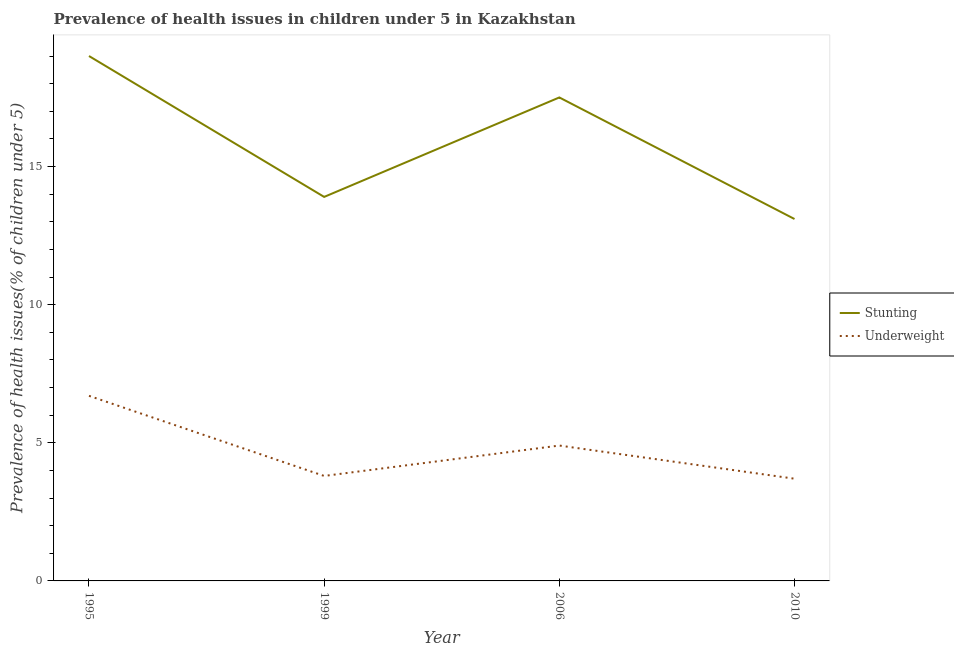How many different coloured lines are there?
Ensure brevity in your answer.  2. Across all years, what is the minimum percentage of stunted children?
Your answer should be very brief. 13.1. What is the total percentage of underweight children in the graph?
Offer a very short reply. 19.1. What is the difference between the percentage of underweight children in 1999 and that in 2006?
Your response must be concise. -1.1. What is the difference between the percentage of underweight children in 1999 and the percentage of stunted children in 2010?
Keep it short and to the point. -9.3. What is the average percentage of stunted children per year?
Ensure brevity in your answer.  15.88. In the year 2010, what is the difference between the percentage of underweight children and percentage of stunted children?
Give a very brief answer. -9.4. In how many years, is the percentage of underweight children greater than 13 %?
Ensure brevity in your answer.  0. What is the ratio of the percentage of stunted children in 1995 to that in 2006?
Offer a very short reply. 1.09. Is the percentage of underweight children in 1995 less than that in 2010?
Keep it short and to the point. No. Is the difference between the percentage of stunted children in 1999 and 2006 greater than the difference between the percentage of underweight children in 1999 and 2006?
Your answer should be compact. No. What is the difference between the highest and the second highest percentage of underweight children?
Keep it short and to the point. 1.8. What is the difference between the highest and the lowest percentage of stunted children?
Keep it short and to the point. 5.9. In how many years, is the percentage of stunted children greater than the average percentage of stunted children taken over all years?
Keep it short and to the point. 2. Does the percentage of underweight children monotonically increase over the years?
Keep it short and to the point. No. Are the values on the major ticks of Y-axis written in scientific E-notation?
Your response must be concise. No. Does the graph contain grids?
Ensure brevity in your answer.  No. What is the title of the graph?
Ensure brevity in your answer.  Prevalence of health issues in children under 5 in Kazakhstan. Does "Food and tobacco" appear as one of the legend labels in the graph?
Your answer should be very brief. No. What is the label or title of the Y-axis?
Ensure brevity in your answer.  Prevalence of health issues(% of children under 5). What is the Prevalence of health issues(% of children under 5) in Stunting in 1995?
Ensure brevity in your answer.  19. What is the Prevalence of health issues(% of children under 5) of Underweight in 1995?
Offer a very short reply. 6.7. What is the Prevalence of health issues(% of children under 5) of Stunting in 1999?
Offer a very short reply. 13.9. What is the Prevalence of health issues(% of children under 5) of Underweight in 1999?
Your answer should be compact. 3.8. What is the Prevalence of health issues(% of children under 5) of Underweight in 2006?
Provide a succinct answer. 4.9. What is the Prevalence of health issues(% of children under 5) of Stunting in 2010?
Give a very brief answer. 13.1. What is the Prevalence of health issues(% of children under 5) in Underweight in 2010?
Provide a succinct answer. 3.7. Across all years, what is the maximum Prevalence of health issues(% of children under 5) of Underweight?
Your response must be concise. 6.7. Across all years, what is the minimum Prevalence of health issues(% of children under 5) of Stunting?
Keep it short and to the point. 13.1. Across all years, what is the minimum Prevalence of health issues(% of children under 5) of Underweight?
Keep it short and to the point. 3.7. What is the total Prevalence of health issues(% of children under 5) in Stunting in the graph?
Offer a terse response. 63.5. What is the difference between the Prevalence of health issues(% of children under 5) of Stunting in 1995 and that in 1999?
Make the answer very short. 5.1. What is the difference between the Prevalence of health issues(% of children under 5) in Underweight in 1995 and that in 1999?
Offer a terse response. 2.9. What is the difference between the Prevalence of health issues(% of children under 5) in Stunting in 1995 and that in 2006?
Your answer should be compact. 1.5. What is the difference between the Prevalence of health issues(% of children under 5) of Underweight in 1995 and that in 2006?
Offer a very short reply. 1.8. What is the difference between the Prevalence of health issues(% of children under 5) in Underweight in 1995 and that in 2010?
Provide a succinct answer. 3. What is the difference between the Prevalence of health issues(% of children under 5) of Stunting in 1999 and that in 2006?
Give a very brief answer. -3.6. What is the difference between the Prevalence of health issues(% of children under 5) of Underweight in 1999 and that in 2006?
Your answer should be compact. -1.1. What is the difference between the Prevalence of health issues(% of children under 5) in Stunting in 1999 and that in 2010?
Keep it short and to the point. 0.8. What is the difference between the Prevalence of health issues(% of children under 5) of Underweight in 1999 and that in 2010?
Keep it short and to the point. 0.1. What is the difference between the Prevalence of health issues(% of children under 5) of Stunting in 1995 and the Prevalence of health issues(% of children under 5) of Underweight in 1999?
Your answer should be compact. 15.2. What is the difference between the Prevalence of health issues(% of children under 5) of Stunting in 1995 and the Prevalence of health issues(% of children under 5) of Underweight in 2006?
Ensure brevity in your answer.  14.1. What is the difference between the Prevalence of health issues(% of children under 5) of Stunting in 1995 and the Prevalence of health issues(% of children under 5) of Underweight in 2010?
Offer a terse response. 15.3. What is the difference between the Prevalence of health issues(% of children under 5) of Stunting in 1999 and the Prevalence of health issues(% of children under 5) of Underweight in 2006?
Provide a succinct answer. 9. What is the difference between the Prevalence of health issues(% of children under 5) of Stunting in 1999 and the Prevalence of health issues(% of children under 5) of Underweight in 2010?
Offer a very short reply. 10.2. What is the average Prevalence of health issues(% of children under 5) in Stunting per year?
Offer a very short reply. 15.88. What is the average Prevalence of health issues(% of children under 5) of Underweight per year?
Offer a very short reply. 4.78. In the year 1995, what is the difference between the Prevalence of health issues(% of children under 5) in Stunting and Prevalence of health issues(% of children under 5) in Underweight?
Provide a short and direct response. 12.3. In the year 1999, what is the difference between the Prevalence of health issues(% of children under 5) of Stunting and Prevalence of health issues(% of children under 5) of Underweight?
Offer a terse response. 10.1. In the year 2006, what is the difference between the Prevalence of health issues(% of children under 5) of Stunting and Prevalence of health issues(% of children under 5) of Underweight?
Make the answer very short. 12.6. What is the ratio of the Prevalence of health issues(% of children under 5) in Stunting in 1995 to that in 1999?
Offer a very short reply. 1.37. What is the ratio of the Prevalence of health issues(% of children under 5) in Underweight in 1995 to that in 1999?
Your answer should be compact. 1.76. What is the ratio of the Prevalence of health issues(% of children under 5) in Stunting in 1995 to that in 2006?
Offer a terse response. 1.09. What is the ratio of the Prevalence of health issues(% of children under 5) in Underweight in 1995 to that in 2006?
Offer a very short reply. 1.37. What is the ratio of the Prevalence of health issues(% of children under 5) of Stunting in 1995 to that in 2010?
Your response must be concise. 1.45. What is the ratio of the Prevalence of health issues(% of children under 5) in Underweight in 1995 to that in 2010?
Provide a succinct answer. 1.81. What is the ratio of the Prevalence of health issues(% of children under 5) in Stunting in 1999 to that in 2006?
Your answer should be very brief. 0.79. What is the ratio of the Prevalence of health issues(% of children under 5) in Underweight in 1999 to that in 2006?
Offer a very short reply. 0.78. What is the ratio of the Prevalence of health issues(% of children under 5) of Stunting in 1999 to that in 2010?
Offer a terse response. 1.06. What is the ratio of the Prevalence of health issues(% of children under 5) of Stunting in 2006 to that in 2010?
Keep it short and to the point. 1.34. What is the ratio of the Prevalence of health issues(% of children under 5) in Underweight in 2006 to that in 2010?
Offer a very short reply. 1.32. What is the difference between the highest and the lowest Prevalence of health issues(% of children under 5) in Stunting?
Your response must be concise. 5.9. 